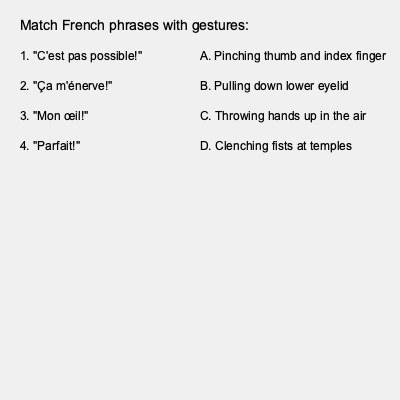As a French language teacher helping non-French-speaking fans understand Marion Cotillard's interviews, match the French phrases with their corresponding gestures or body language commonly used in French culture. Which gesture corresponds to the phrase "C'est pas possible!"? To answer this question, let's analyze each phrase and its corresponding gesture:

1. "C'est pas possible!" (It's not possible!):
   This expression conveys disbelief or exasperation. In French culture, it's often accompanied by throwing hands up in the air, which is option C.

2. "Ça m'énerve!" (It's annoying me!):
   This phrase expresses frustration or anger. It's typically associated with clenching fists at temples, which is option D.

3. "Mon œil!" (My eye! / Yeah, right!):
   This is a sarcastic expression of disbelief. It's usually accompanied by pulling down the lower eyelid, which is option B.

4. "Parfait!" (Perfect!):
   This expression indicates approval or satisfaction. In French gestures, it's often shown by pinching the thumb and index finger together, which is option A.

Therefore, the gesture that corresponds to "C'est pas possible!" is throwing hands up in the air.
Answer: Throwing hands up in the air 